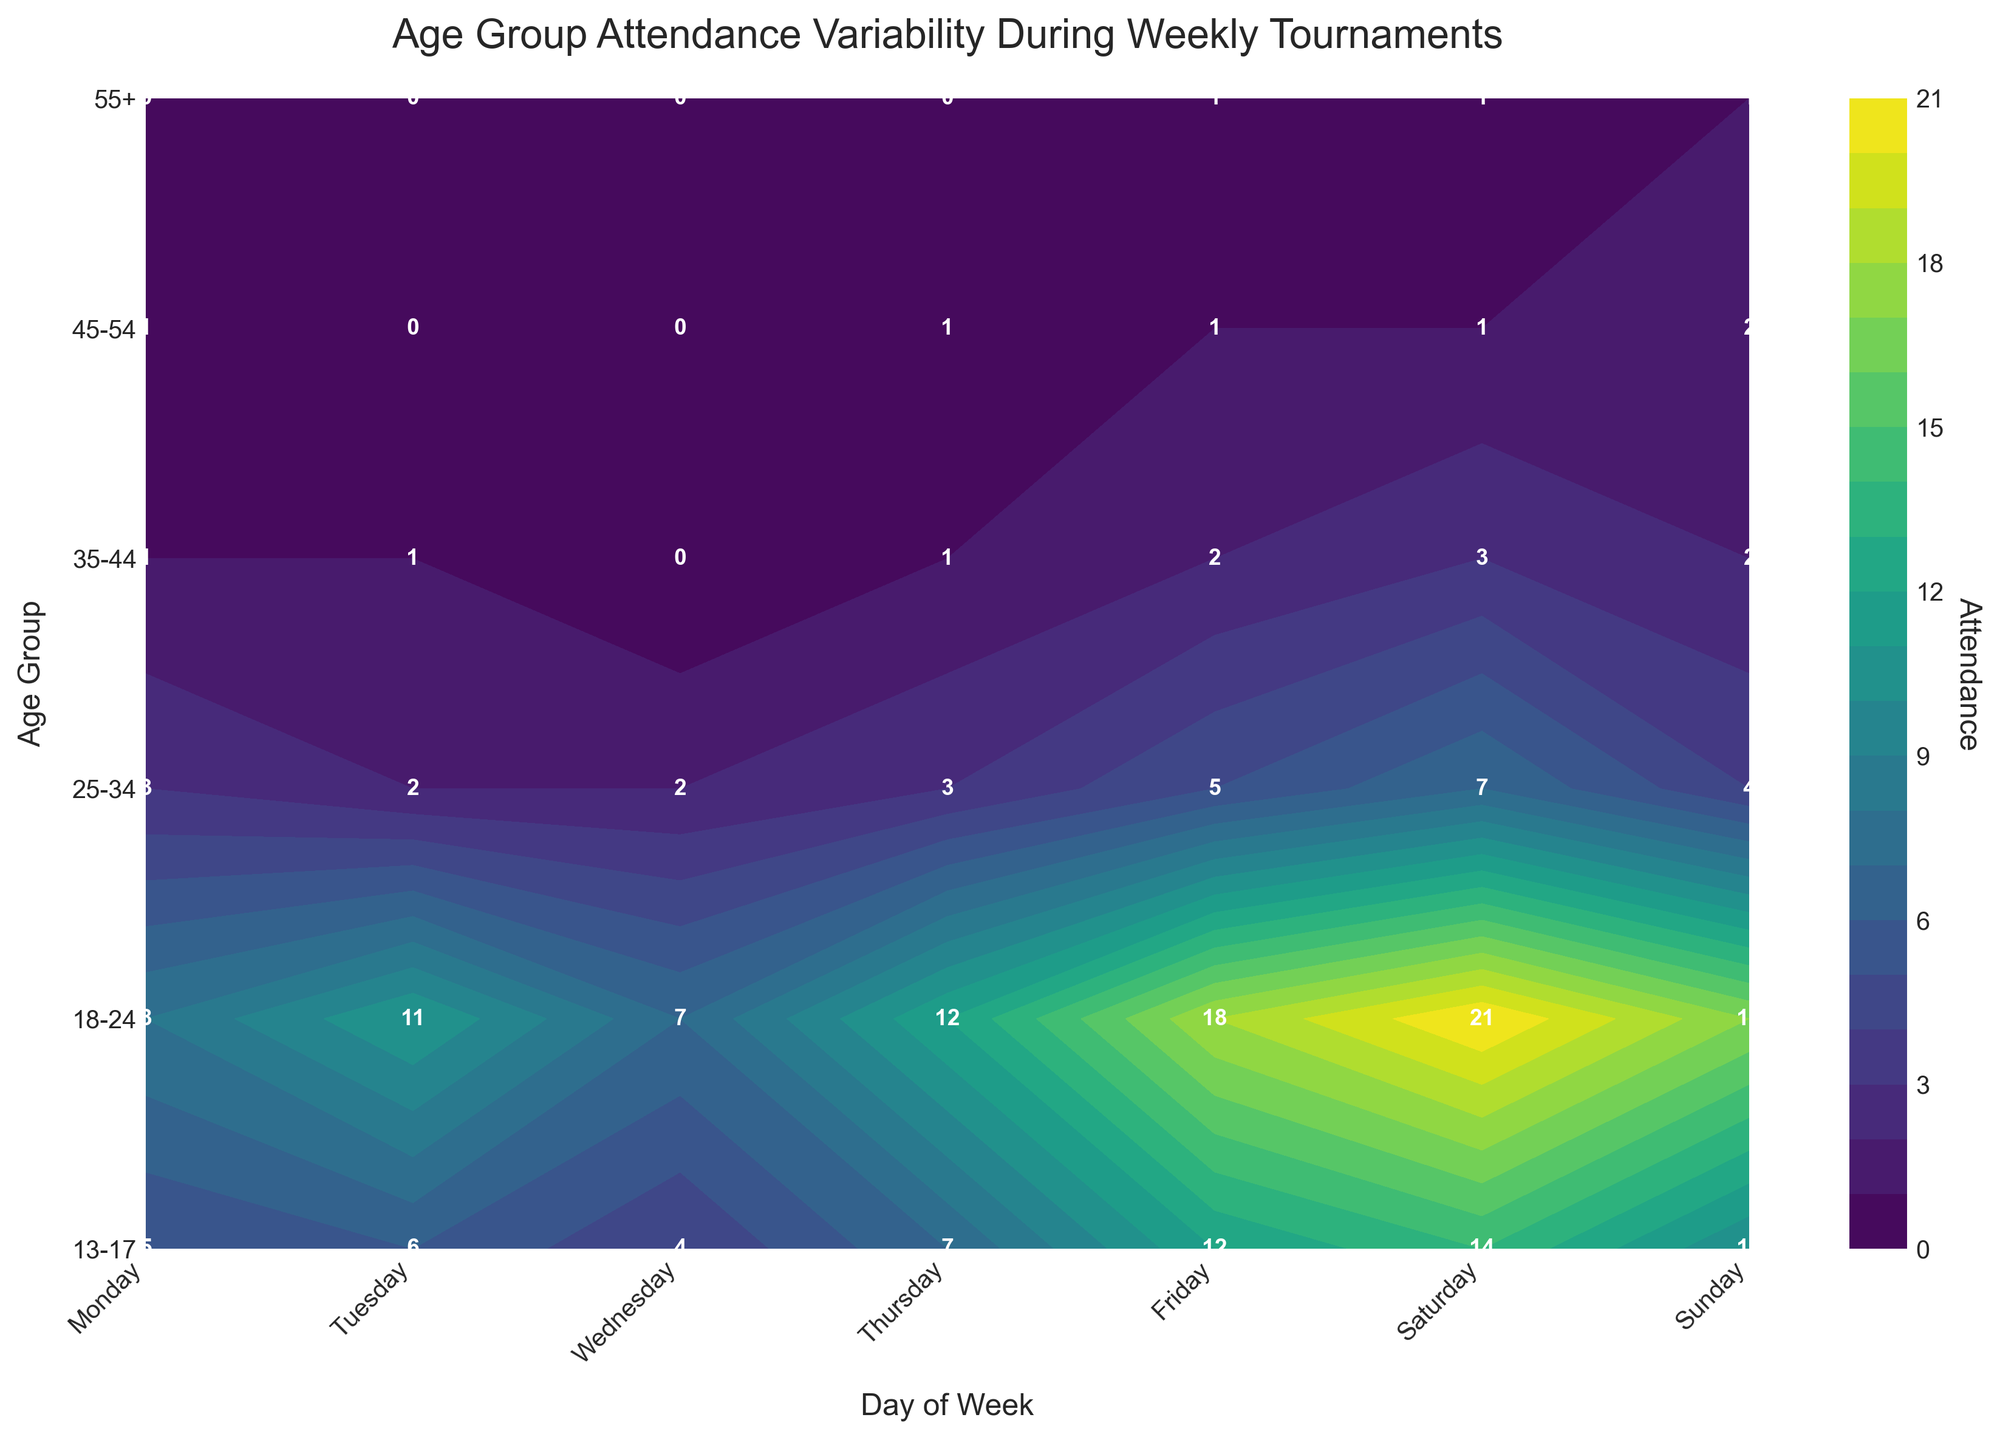What is the title of the plot? The title is usually displayed at the top of the figure in a larger font size, in this case, it reads 'Age Group Attendance Variability During Weekly Tournaments'.
Answer: Age Group Attendance Variability During Weekly Tournaments Which day of the week has the highest attendance for the 18-24 age group? Look for the highest label number in the row corresponding to the 18-24 age group. The highest label number is 21 on Saturday.
Answer: Saturday What is the attendance for the 25-34 age group on Wednesday? Find the intersection of the 25-34 age group row and the Wednesday column. The number at this intersection is 2.
Answer: 2 On which day does the 55+ age group have their highest attendance? Locate the highest number in the 55+ age group row. The highest number is 1, which occurs on Friday, Saturday, and Sunday.
Answer: Friday, Saturday, and Sunday How does the attendance for the 13-17 age group compare between Monday and Friday? Find the attendance numbers for the 13-17 age group on Monday and Friday. On Monday, the attendance is 5, and on Friday, it is 12. The attendance on Friday is higher.
Answer: Higher on Friday Which age group has the lowest average attendance throughout the week? Compute the average attendance for each age group by summing their attendance across all days and dividing by 7. The 55+ age group has an average attendance of 0.3, which is the lowest.
Answer: 55+ What's the total attendance for all age groups on Saturday? Sum the attendance numbers for all age groups on Saturday. Adding 14 (13-17) + 21 (18-24) + 7 (25-34) + 3 (35-44) + 1 (45-54) + 1 (55+) results in 47.
Answer: 47 Which day of the week has the highest total attendance across all age groups? Sum the attendance numbers for all age groups for each day of the week. Saturday has the highest total with 47.
Answer: Saturday What is the average attendance for the 18-24 age group from Thursday to Sunday? Add the attendance from Thursday (12), Friday (18), Saturday (21), and Sunday (17) and divide by 4. (12 + 18 + 21 + 17) / 4 = 68 / 4 = 17.
Answer: 17 How much higher is the attendance for the 13-17 age group on Sunday compared to Wednesday? Subtract the attendance on Wednesday from the attendance on Sunday for the 13-17 age group. 10 (Sunday) - 4 (Wednesday) = 6.
Answer: 6 